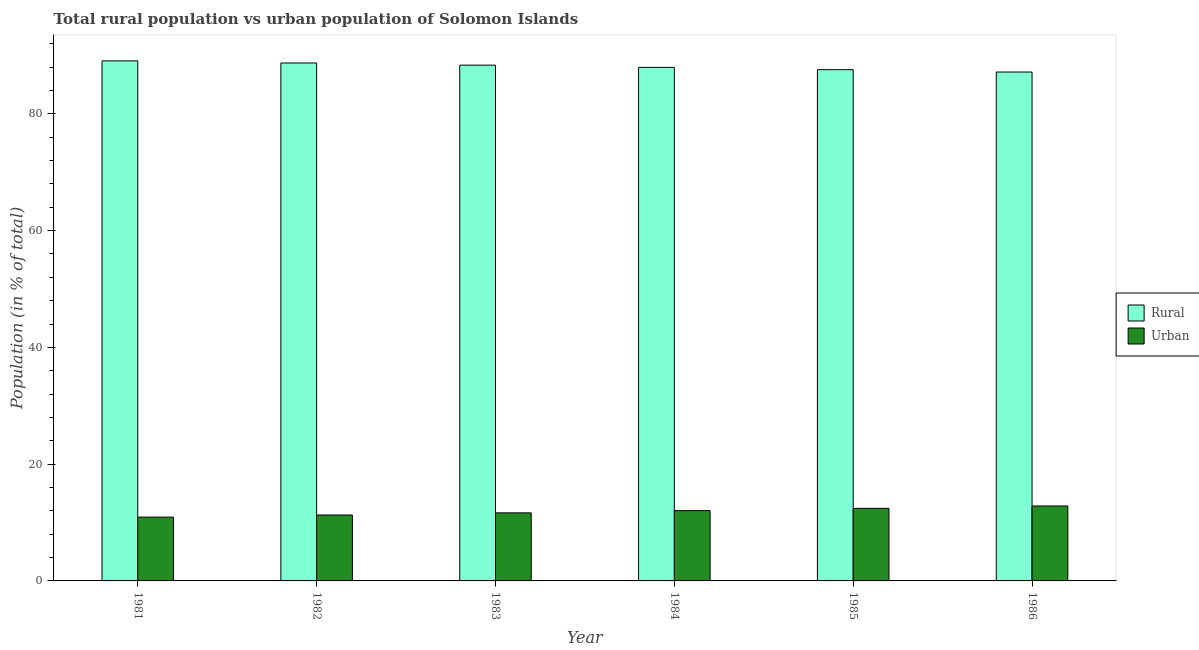Are the number of bars per tick equal to the number of legend labels?
Offer a very short reply. Yes. Are the number of bars on each tick of the X-axis equal?
Offer a very short reply. Yes. What is the label of the 2nd group of bars from the left?
Make the answer very short. 1982. In how many cases, is the number of bars for a given year not equal to the number of legend labels?
Make the answer very short. 0. What is the rural population in 1982?
Keep it short and to the point. 88.71. Across all years, what is the maximum urban population?
Offer a terse response. 12.84. Across all years, what is the minimum urban population?
Offer a very short reply. 10.93. In which year was the urban population maximum?
Keep it short and to the point. 1986. In which year was the rural population minimum?
Your answer should be very brief. 1986. What is the total rural population in the graph?
Provide a succinct answer. 528.82. What is the difference between the rural population in 1983 and that in 1986?
Give a very brief answer. 1.18. What is the difference between the urban population in 1986 and the rural population in 1981?
Provide a short and direct response. 1.91. What is the average rural population per year?
Offer a terse response. 88.14. In the year 1983, what is the difference between the urban population and rural population?
Provide a short and direct response. 0. In how many years, is the rural population greater than 60 %?
Keep it short and to the point. 6. What is the ratio of the urban population in 1982 to that in 1983?
Make the answer very short. 0.97. Is the difference between the urban population in 1982 and 1983 greater than the difference between the rural population in 1982 and 1983?
Your answer should be compact. No. What is the difference between the highest and the second highest rural population?
Offer a very short reply. 0.36. What is the difference between the highest and the lowest urban population?
Make the answer very short. 1.91. In how many years, is the rural population greater than the average rural population taken over all years?
Your response must be concise. 3. Is the sum of the urban population in 1982 and 1986 greater than the maximum rural population across all years?
Make the answer very short. Yes. What does the 1st bar from the left in 1981 represents?
Your answer should be very brief. Rural. What does the 2nd bar from the right in 1983 represents?
Your response must be concise. Rural. How many bars are there?
Provide a succinct answer. 12. Does the graph contain any zero values?
Give a very brief answer. No. Does the graph contain grids?
Offer a terse response. No. Where does the legend appear in the graph?
Ensure brevity in your answer.  Center right. How many legend labels are there?
Keep it short and to the point. 2. How are the legend labels stacked?
Give a very brief answer. Vertical. What is the title of the graph?
Provide a short and direct response. Total rural population vs urban population of Solomon Islands. What is the label or title of the Y-axis?
Give a very brief answer. Population (in % of total). What is the Population (in % of total) in Rural in 1981?
Keep it short and to the point. 89.07. What is the Population (in % of total) of Urban in 1981?
Ensure brevity in your answer.  10.93. What is the Population (in % of total) in Rural in 1982?
Provide a short and direct response. 88.71. What is the Population (in % of total) in Urban in 1982?
Keep it short and to the point. 11.29. What is the Population (in % of total) in Rural in 1983?
Offer a terse response. 88.34. What is the Population (in % of total) of Urban in 1983?
Offer a terse response. 11.66. What is the Population (in % of total) of Rural in 1984?
Ensure brevity in your answer.  87.96. What is the Population (in % of total) of Urban in 1984?
Give a very brief answer. 12.04. What is the Population (in % of total) in Rural in 1985?
Give a very brief answer. 87.57. What is the Population (in % of total) of Urban in 1985?
Keep it short and to the point. 12.43. What is the Population (in % of total) of Rural in 1986?
Ensure brevity in your answer.  87.16. What is the Population (in % of total) of Urban in 1986?
Offer a terse response. 12.84. Across all years, what is the maximum Population (in % of total) of Rural?
Offer a terse response. 89.07. Across all years, what is the maximum Population (in % of total) of Urban?
Make the answer very short. 12.84. Across all years, what is the minimum Population (in % of total) in Rural?
Give a very brief answer. 87.16. Across all years, what is the minimum Population (in % of total) of Urban?
Your response must be concise. 10.93. What is the total Population (in % of total) of Rural in the graph?
Your answer should be very brief. 528.82. What is the total Population (in % of total) in Urban in the graph?
Your answer should be very brief. 71.19. What is the difference between the Population (in % of total) of Rural in 1981 and that in 1982?
Offer a terse response. 0.36. What is the difference between the Population (in % of total) of Urban in 1981 and that in 1982?
Make the answer very short. -0.36. What is the difference between the Population (in % of total) in Rural in 1981 and that in 1983?
Your answer should be compact. 0.73. What is the difference between the Population (in % of total) of Urban in 1981 and that in 1983?
Give a very brief answer. -0.73. What is the difference between the Population (in % of total) in Rural in 1981 and that in 1984?
Offer a terse response. 1.11. What is the difference between the Population (in % of total) of Urban in 1981 and that in 1984?
Offer a very short reply. -1.11. What is the difference between the Population (in % of total) in Rural in 1981 and that in 1985?
Your answer should be very brief. 1.51. What is the difference between the Population (in % of total) in Urban in 1981 and that in 1985?
Make the answer very short. -1.51. What is the difference between the Population (in % of total) in Rural in 1981 and that in 1986?
Give a very brief answer. 1.91. What is the difference between the Population (in % of total) in Urban in 1981 and that in 1986?
Your answer should be very brief. -1.91. What is the difference between the Population (in % of total) in Rural in 1982 and that in 1983?
Provide a succinct answer. 0.37. What is the difference between the Population (in % of total) in Urban in 1982 and that in 1983?
Offer a terse response. -0.37. What is the difference between the Population (in % of total) of Rural in 1982 and that in 1984?
Your answer should be very brief. 0.75. What is the difference between the Population (in % of total) of Urban in 1982 and that in 1984?
Ensure brevity in your answer.  -0.75. What is the difference between the Population (in % of total) of Rural in 1982 and that in 1985?
Your answer should be compact. 1.15. What is the difference between the Population (in % of total) of Urban in 1982 and that in 1985?
Offer a terse response. -1.15. What is the difference between the Population (in % of total) of Rural in 1982 and that in 1986?
Ensure brevity in your answer.  1.55. What is the difference between the Population (in % of total) of Urban in 1982 and that in 1986?
Keep it short and to the point. -1.55. What is the difference between the Population (in % of total) of Rural in 1983 and that in 1984?
Provide a short and direct response. 0.38. What is the difference between the Population (in % of total) in Urban in 1983 and that in 1984?
Keep it short and to the point. -0.38. What is the difference between the Population (in % of total) of Rural in 1983 and that in 1985?
Offer a very short reply. 0.77. What is the difference between the Population (in % of total) in Urban in 1983 and that in 1985?
Keep it short and to the point. -0.77. What is the difference between the Population (in % of total) in Rural in 1983 and that in 1986?
Give a very brief answer. 1.18. What is the difference between the Population (in % of total) of Urban in 1983 and that in 1986?
Provide a short and direct response. -1.18. What is the difference between the Population (in % of total) of Rural in 1984 and that in 1985?
Offer a very short reply. 0.39. What is the difference between the Population (in % of total) in Urban in 1984 and that in 1985?
Your answer should be compact. -0.39. What is the difference between the Population (in % of total) in Rural in 1984 and that in 1986?
Your response must be concise. 0.8. What is the difference between the Population (in % of total) in Urban in 1984 and that in 1986?
Provide a succinct answer. -0.8. What is the difference between the Population (in % of total) in Rural in 1985 and that in 1986?
Your answer should be very brief. 0.4. What is the difference between the Population (in % of total) of Urban in 1985 and that in 1986?
Your response must be concise. -0.4. What is the difference between the Population (in % of total) in Rural in 1981 and the Population (in % of total) in Urban in 1982?
Your answer should be very brief. 77.78. What is the difference between the Population (in % of total) in Rural in 1981 and the Population (in % of total) in Urban in 1983?
Ensure brevity in your answer.  77.41. What is the difference between the Population (in % of total) of Rural in 1981 and the Population (in % of total) of Urban in 1984?
Provide a succinct answer. 77.03. What is the difference between the Population (in % of total) in Rural in 1981 and the Population (in % of total) in Urban in 1985?
Your answer should be very brief. 76.64. What is the difference between the Population (in % of total) of Rural in 1981 and the Population (in % of total) of Urban in 1986?
Offer a very short reply. 76.24. What is the difference between the Population (in % of total) in Rural in 1982 and the Population (in % of total) in Urban in 1983?
Make the answer very short. 77.05. What is the difference between the Population (in % of total) in Rural in 1982 and the Population (in % of total) in Urban in 1984?
Provide a short and direct response. 76.67. What is the difference between the Population (in % of total) in Rural in 1982 and the Population (in % of total) in Urban in 1985?
Your response must be concise. 76.28. What is the difference between the Population (in % of total) in Rural in 1982 and the Population (in % of total) in Urban in 1986?
Provide a succinct answer. 75.88. What is the difference between the Population (in % of total) of Rural in 1983 and the Population (in % of total) of Urban in 1984?
Make the answer very short. 76.3. What is the difference between the Population (in % of total) of Rural in 1983 and the Population (in % of total) of Urban in 1985?
Your response must be concise. 75.91. What is the difference between the Population (in % of total) of Rural in 1983 and the Population (in % of total) of Urban in 1986?
Your answer should be very brief. 75.5. What is the difference between the Population (in % of total) of Rural in 1984 and the Population (in % of total) of Urban in 1985?
Provide a short and direct response. 75.53. What is the difference between the Population (in % of total) in Rural in 1984 and the Population (in % of total) in Urban in 1986?
Give a very brief answer. 75.12. What is the difference between the Population (in % of total) of Rural in 1985 and the Population (in % of total) of Urban in 1986?
Offer a terse response. 74.73. What is the average Population (in % of total) of Rural per year?
Provide a short and direct response. 88.14. What is the average Population (in % of total) in Urban per year?
Keep it short and to the point. 11.86. In the year 1981, what is the difference between the Population (in % of total) of Rural and Population (in % of total) of Urban?
Your answer should be compact. 78.15. In the year 1982, what is the difference between the Population (in % of total) in Rural and Population (in % of total) in Urban?
Provide a short and direct response. 77.42. In the year 1983, what is the difference between the Population (in % of total) of Rural and Population (in % of total) of Urban?
Offer a terse response. 76.68. In the year 1984, what is the difference between the Population (in % of total) in Rural and Population (in % of total) in Urban?
Your answer should be compact. 75.92. In the year 1985, what is the difference between the Population (in % of total) in Rural and Population (in % of total) in Urban?
Provide a succinct answer. 75.13. In the year 1986, what is the difference between the Population (in % of total) of Rural and Population (in % of total) of Urban?
Ensure brevity in your answer.  74.33. What is the ratio of the Population (in % of total) of Rural in 1981 to that in 1982?
Give a very brief answer. 1. What is the ratio of the Population (in % of total) of Rural in 1981 to that in 1983?
Your answer should be very brief. 1.01. What is the ratio of the Population (in % of total) in Urban in 1981 to that in 1983?
Offer a very short reply. 0.94. What is the ratio of the Population (in % of total) of Rural in 1981 to that in 1984?
Provide a short and direct response. 1.01. What is the ratio of the Population (in % of total) in Urban in 1981 to that in 1984?
Make the answer very short. 0.91. What is the ratio of the Population (in % of total) in Rural in 1981 to that in 1985?
Provide a short and direct response. 1.02. What is the ratio of the Population (in % of total) of Urban in 1981 to that in 1985?
Your answer should be compact. 0.88. What is the ratio of the Population (in % of total) of Rural in 1981 to that in 1986?
Your answer should be compact. 1.02. What is the ratio of the Population (in % of total) in Urban in 1981 to that in 1986?
Your response must be concise. 0.85. What is the ratio of the Population (in % of total) in Urban in 1982 to that in 1983?
Offer a terse response. 0.97. What is the ratio of the Population (in % of total) of Rural in 1982 to that in 1984?
Make the answer very short. 1.01. What is the ratio of the Population (in % of total) in Rural in 1982 to that in 1985?
Your answer should be very brief. 1.01. What is the ratio of the Population (in % of total) in Urban in 1982 to that in 1985?
Provide a succinct answer. 0.91. What is the ratio of the Population (in % of total) in Rural in 1982 to that in 1986?
Offer a very short reply. 1.02. What is the ratio of the Population (in % of total) in Urban in 1982 to that in 1986?
Make the answer very short. 0.88. What is the ratio of the Population (in % of total) of Urban in 1983 to that in 1984?
Offer a very short reply. 0.97. What is the ratio of the Population (in % of total) of Rural in 1983 to that in 1985?
Ensure brevity in your answer.  1.01. What is the ratio of the Population (in % of total) of Urban in 1983 to that in 1985?
Offer a very short reply. 0.94. What is the ratio of the Population (in % of total) in Rural in 1983 to that in 1986?
Ensure brevity in your answer.  1.01. What is the ratio of the Population (in % of total) in Urban in 1983 to that in 1986?
Ensure brevity in your answer.  0.91. What is the ratio of the Population (in % of total) in Rural in 1984 to that in 1985?
Provide a short and direct response. 1. What is the ratio of the Population (in % of total) in Urban in 1984 to that in 1985?
Keep it short and to the point. 0.97. What is the ratio of the Population (in % of total) in Rural in 1984 to that in 1986?
Provide a succinct answer. 1.01. What is the ratio of the Population (in % of total) of Urban in 1984 to that in 1986?
Make the answer very short. 0.94. What is the ratio of the Population (in % of total) of Rural in 1985 to that in 1986?
Offer a very short reply. 1. What is the ratio of the Population (in % of total) in Urban in 1985 to that in 1986?
Provide a succinct answer. 0.97. What is the difference between the highest and the second highest Population (in % of total) in Rural?
Offer a very short reply. 0.36. What is the difference between the highest and the second highest Population (in % of total) of Urban?
Make the answer very short. 0.4. What is the difference between the highest and the lowest Population (in % of total) in Rural?
Provide a short and direct response. 1.91. What is the difference between the highest and the lowest Population (in % of total) in Urban?
Offer a very short reply. 1.91. 